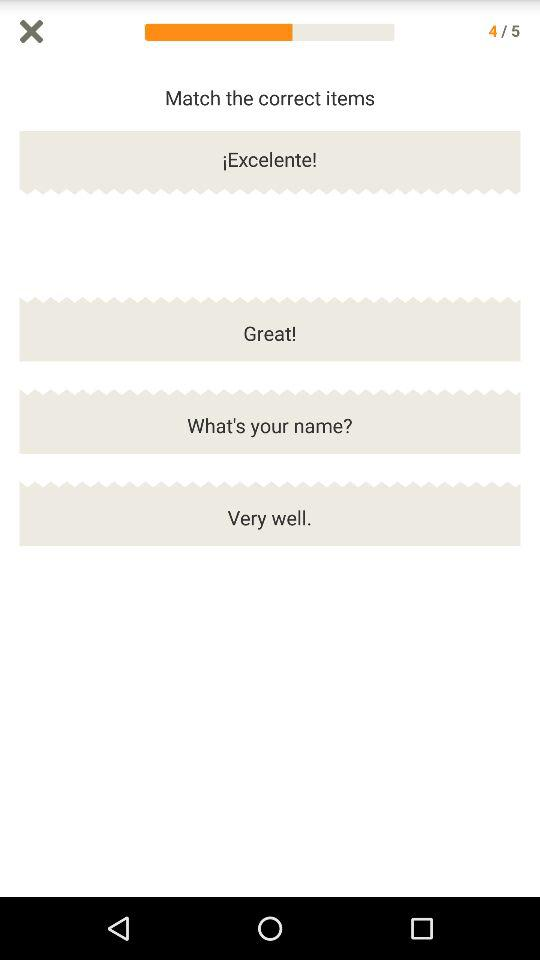Which slide are we on? You are on the fourth slide. 